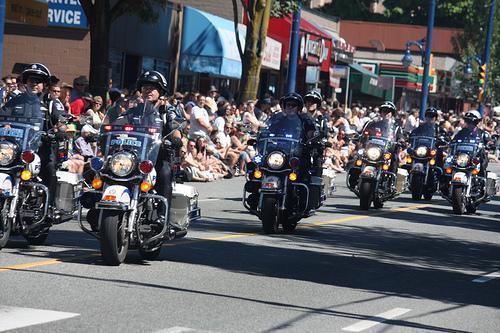How many motorcycles are there?
Give a very brief answer. 6. 